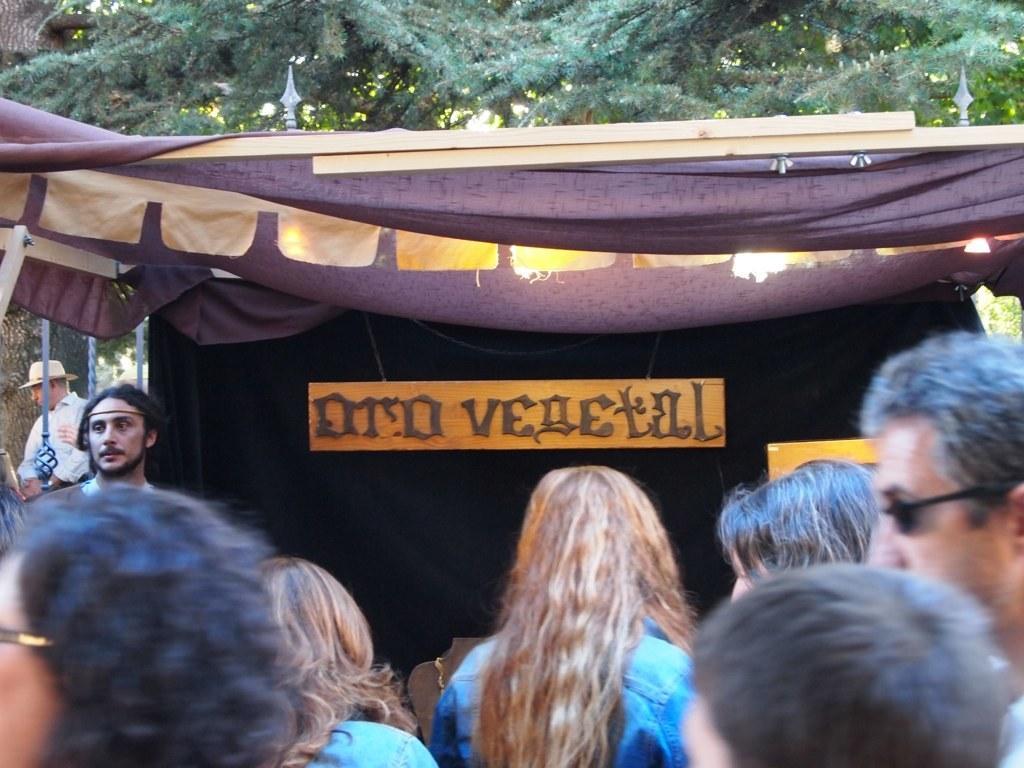Could you give a brief overview of what you see in this image? In this image we can see a group of people. On the backside we can see a tree and a tent with a board on it. 